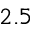Convert formula to latex. <formula><loc_0><loc_0><loc_500><loc_500>2 . 5</formula> 